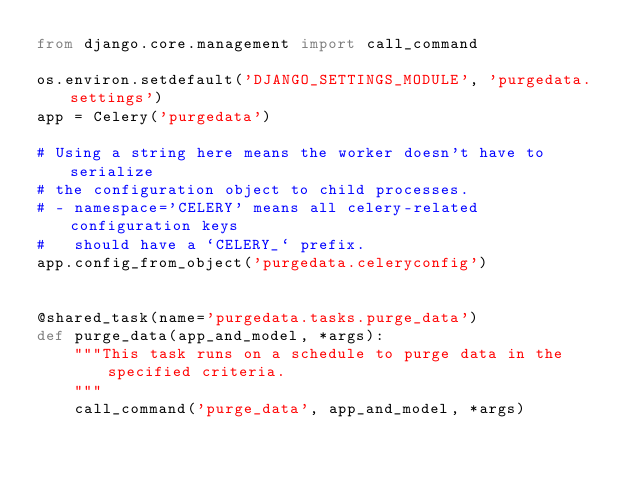<code> <loc_0><loc_0><loc_500><loc_500><_Python_>from django.core.management import call_command

os.environ.setdefault('DJANGO_SETTINGS_MODULE', 'purgedata.settings')
app = Celery('purgedata')

# Using a string here means the worker doesn't have to serialize
# the configuration object to child processes.
# - namespace='CELERY' means all celery-related configuration keys
#   should have a `CELERY_` prefix.
app.config_from_object('purgedata.celeryconfig')


@shared_task(name='purgedata.tasks.purge_data')
def purge_data(app_and_model, *args):
    """This task runs on a schedule to purge data in the specified criteria.
    """
    call_command('purge_data', app_and_model, *args)
</code> 